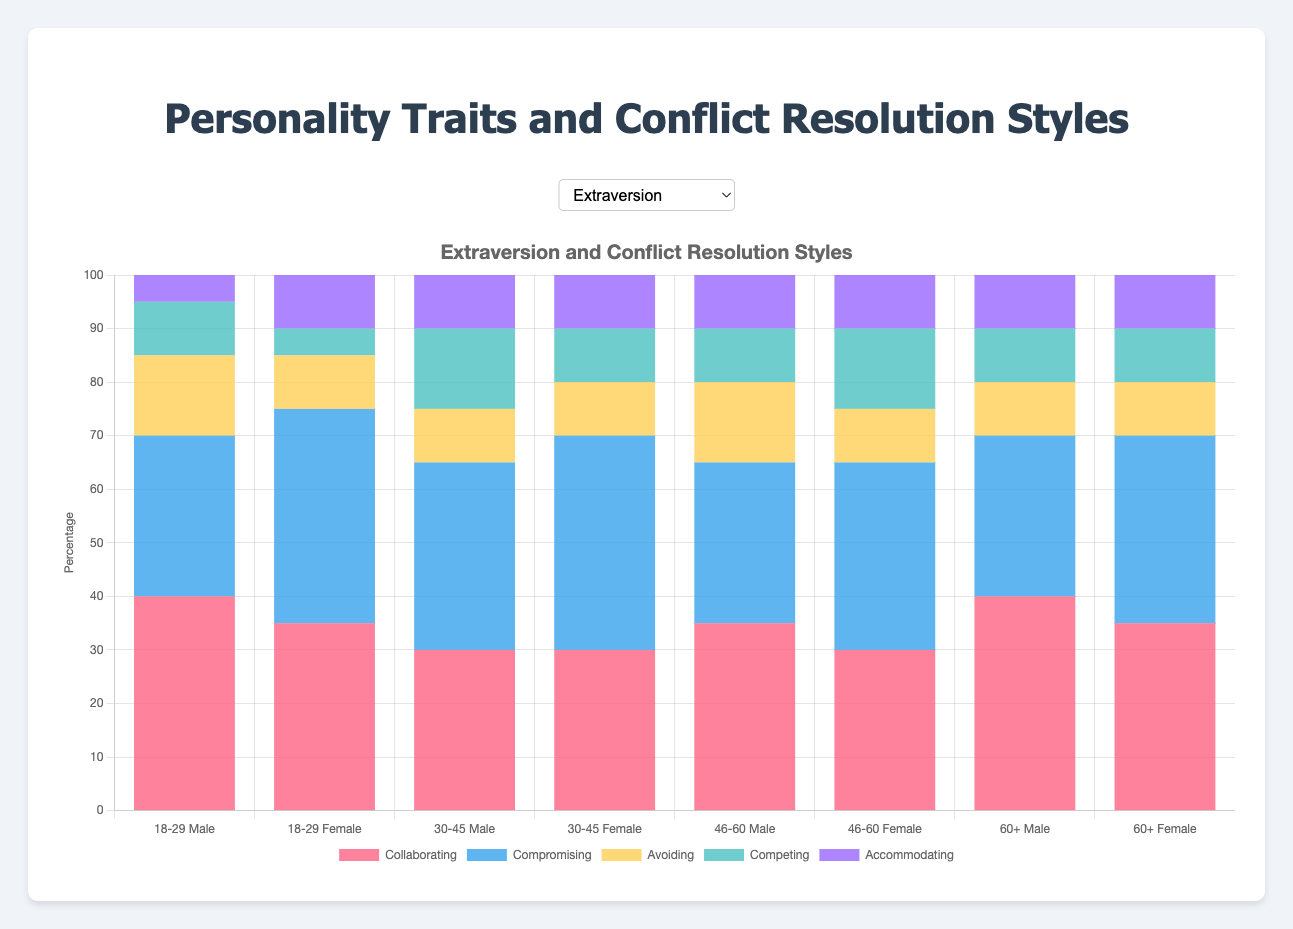What conflict resolution style is most preferred by males aged 18-29 with an extraversion trait? The figure displays that for males aged 18-29 with an extraversion trait, collaborating has the tallest bar. This indicates it is the most preferred style among the given options.
Answer: Collaborating How does the preference for competing differ between males and females aged 46-60 with a conscientiousness trait? For males in the 46-60 age group with a conscientiousness trait, the bar for competing is higher than for females. Specifically, males have a value of 25, while females have a value of 20.
Answer: More males prefer competing Which age group and gender combination shows the highest preference for accommodating among those with an agreeableness trait? The highest preference for accommodating in the agreeableness trait across age groups and genders is found by comparing the height of the bar labeled accommodating in all subgroups. All values are equal except for the males aged 18-29.
Answer: Equal preferences Which conflict resolution style has an equal preference rate among all females aged 60+ with different traits? By observing the figure for females aged 60+, the bar labeled accommodating is identical across all three traits: extraversion, agreeableness, and conscientiousness, each at the height of 10.
Answer: Accommodating Calculate the difference in preference for collaborating between males aged 30-45 with an extraversion trait and females aged 18-29 with the same trait. The bar for males aged 30-45 with an extraversion trait for collaborating is 30, and for females aged 18-29 with an extraversion trait, it is 35. The difference is 35 - 30 = 5.
Answer: 5 Which trait shows the lowest preference for avoiding among females aged 18-29? In the figure displaying the preferences of females aged 18-29, the shortest bar for avoiding is in the agreeableness trait, which is 10.
Answer: Agreeableness Compare the preference for compromising between males aged 60+ and females aged 46-60, both with an extraversion trait. In the figure, for males aged 60+ with extraversion, the bar for compromising is at 30, and for females aged 46-60 with extraversion, it is at 35.
Answer: Females prefer compromising more 